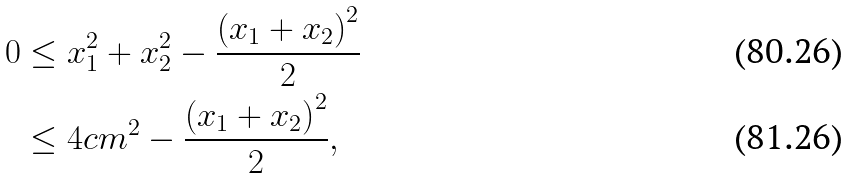<formula> <loc_0><loc_0><loc_500><loc_500>0 & \leq x _ { 1 } ^ { 2 } + x _ { 2 } ^ { 2 } - \frac { \left ( x _ { 1 } + x _ { 2 } \right ) ^ { 2 } } { 2 } \\ & \leq 4 c m ^ { 2 } - \frac { \left ( x _ { 1 } + x _ { 2 } \right ) ^ { 2 } } { 2 } ,</formula> 